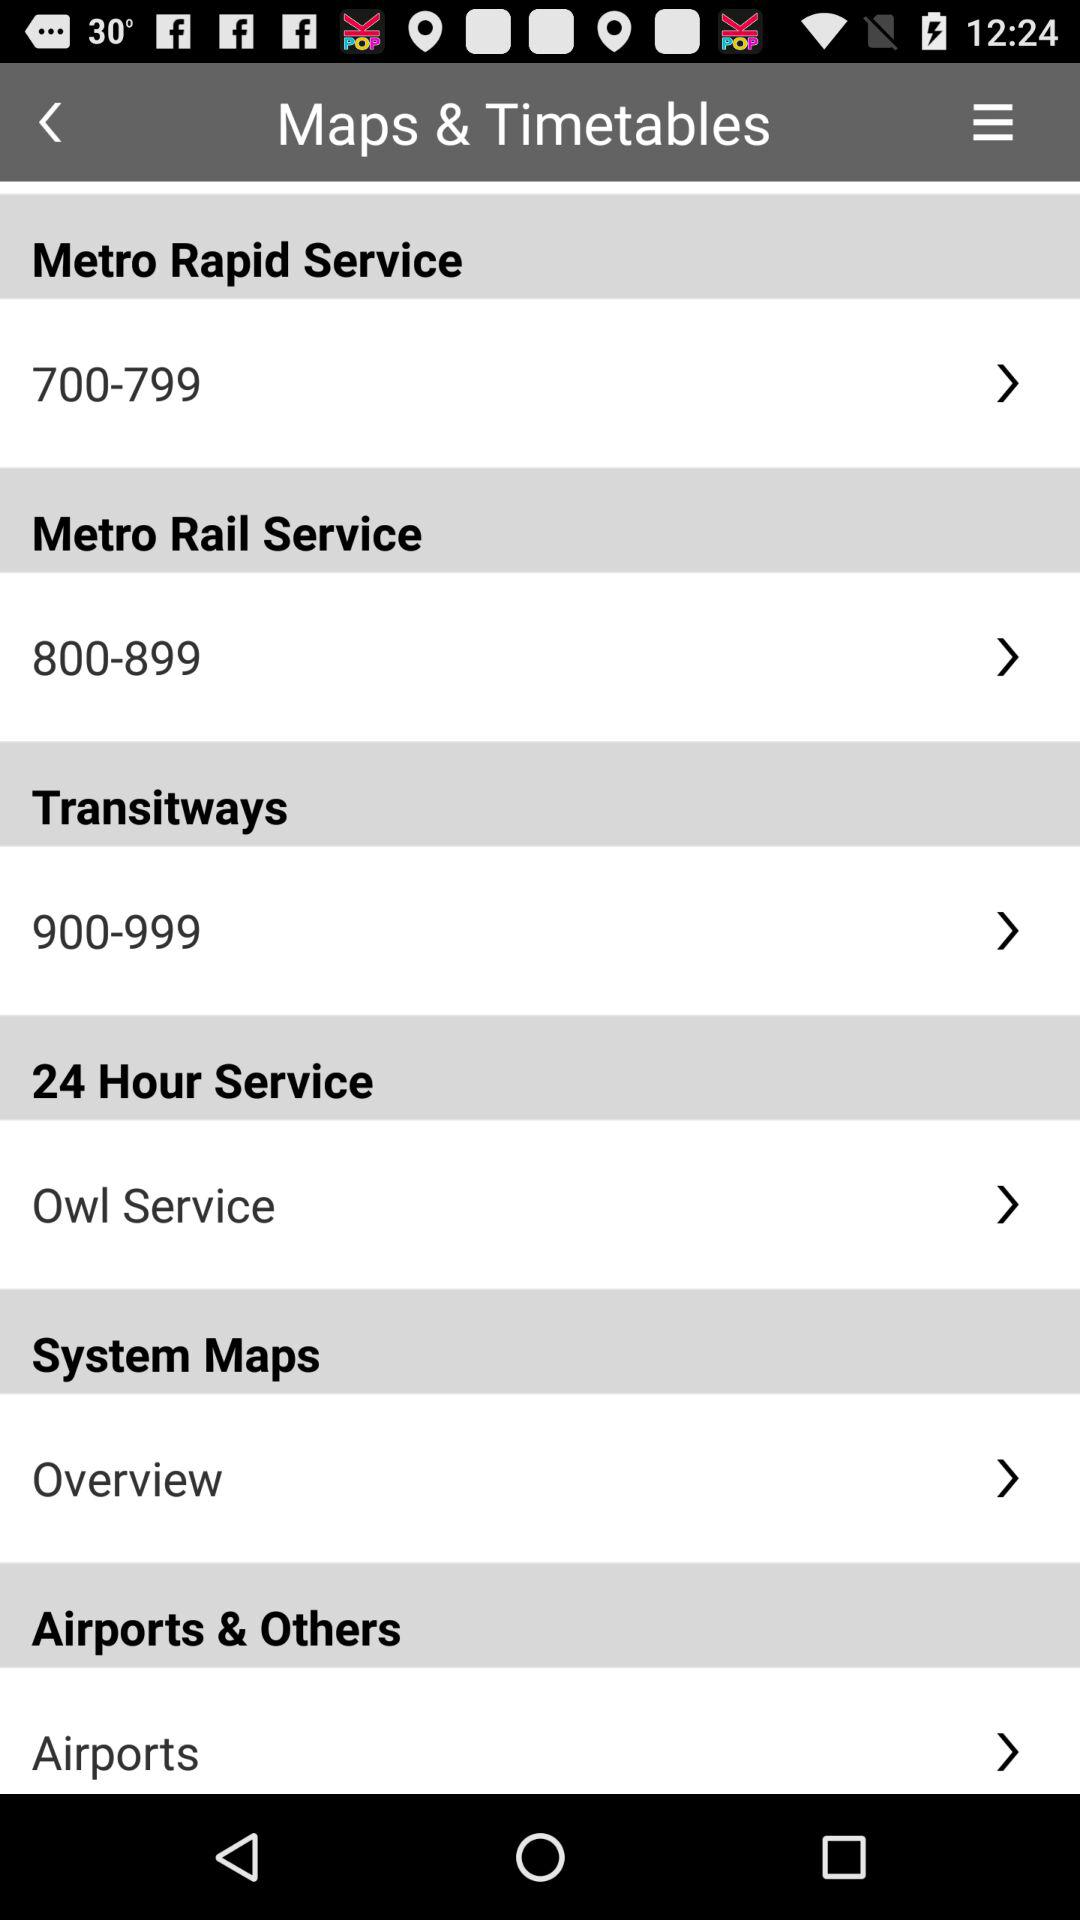Which service is used 24 hours a day? The used service 24 hours a day is the Owl Service. 